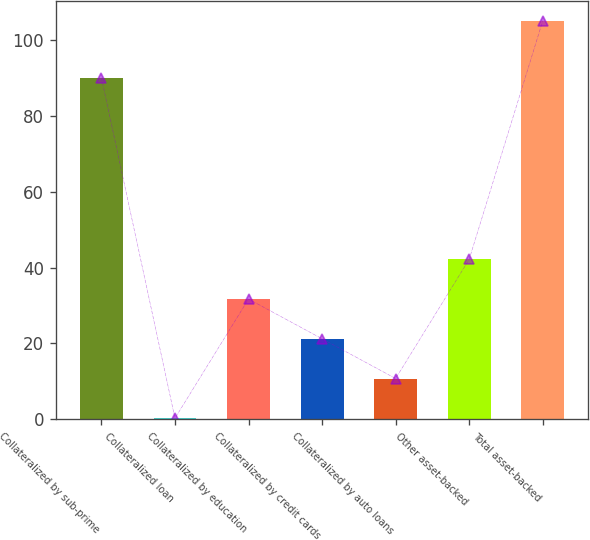Convert chart to OTSL. <chart><loc_0><loc_0><loc_500><loc_500><bar_chart><fcel>Collateralized by sub-prime<fcel>Collateralized loan<fcel>Collateralized by education<fcel>Collateralized by credit cards<fcel>Collateralized by auto loans<fcel>Other asset-backed<fcel>Total asset-backed<nl><fcel>90<fcel>0.29<fcel>31.7<fcel>21.23<fcel>10.76<fcel>42.17<fcel>105<nl></chart> 